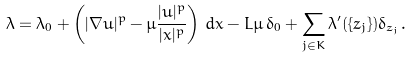<formula> <loc_0><loc_0><loc_500><loc_500>\lambda = \lambda _ { 0 } + \left ( | \nabla u | ^ { p } - \mu \frac { | u | ^ { p } } { | x | ^ { p } } \right ) \, d x - L \mu \, \delta _ { 0 } + \sum _ { j \in K } \lambda ^ { \prime } ( \{ z _ { j } \} ) \delta _ { z _ { j } } .</formula> 